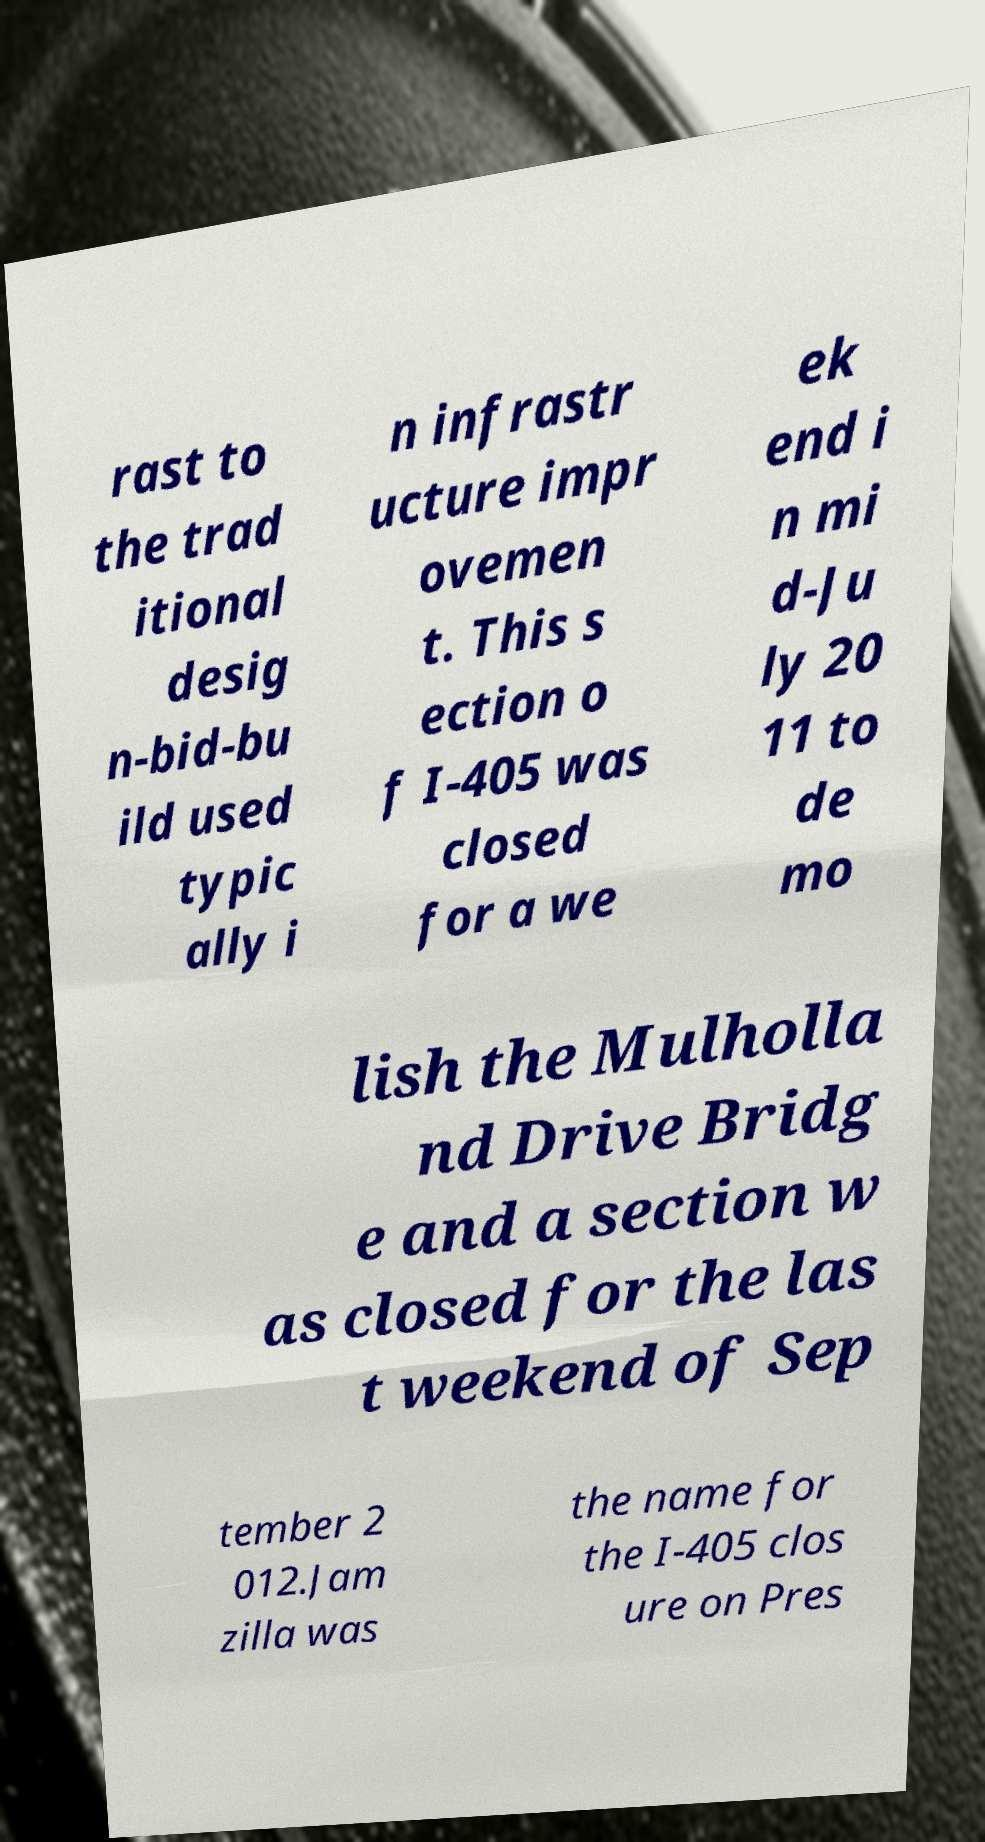Could you extract and type out the text from this image? rast to the trad itional desig n-bid-bu ild used typic ally i n infrastr ucture impr ovemen t. This s ection o f I-405 was closed for a we ek end i n mi d-Ju ly 20 11 to de mo lish the Mulholla nd Drive Bridg e and a section w as closed for the las t weekend of Sep tember 2 012.Jam zilla was the name for the I-405 clos ure on Pres 